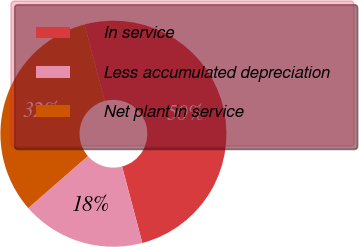Convert chart to OTSL. <chart><loc_0><loc_0><loc_500><loc_500><pie_chart><fcel>In service<fcel>Less accumulated depreciation<fcel>Net plant in service<nl><fcel>50.0%<fcel>17.69%<fcel>32.31%<nl></chart> 